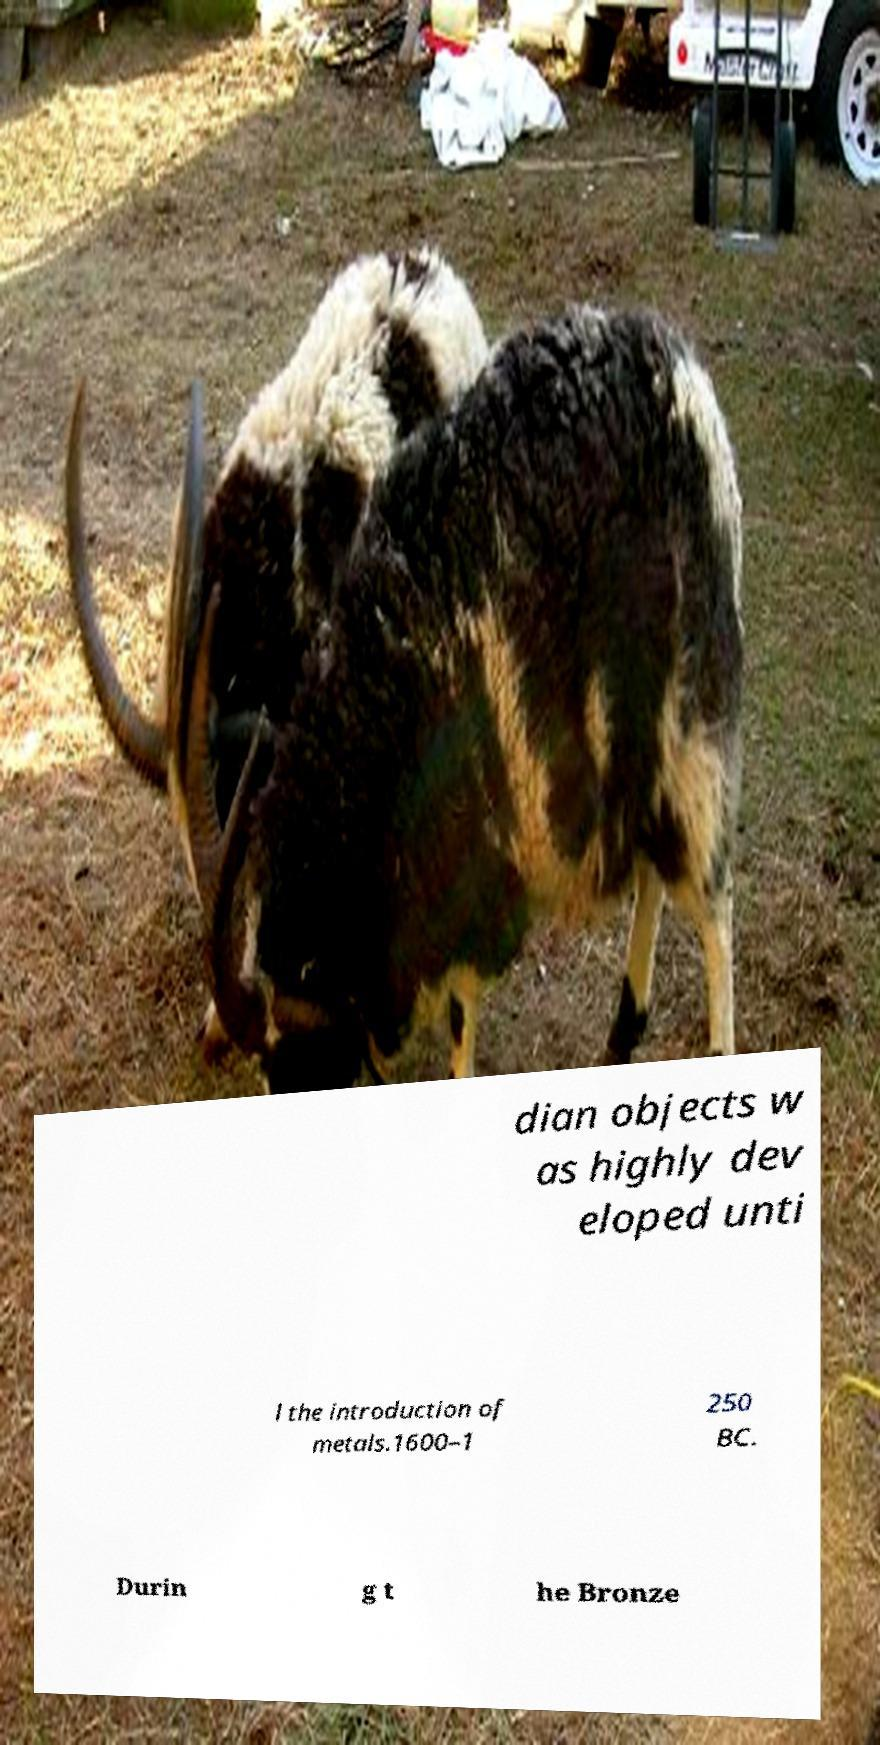Can you accurately transcribe the text from the provided image for me? dian objects w as highly dev eloped unti l the introduction of metals.1600–1 250 BC. Durin g t he Bronze 